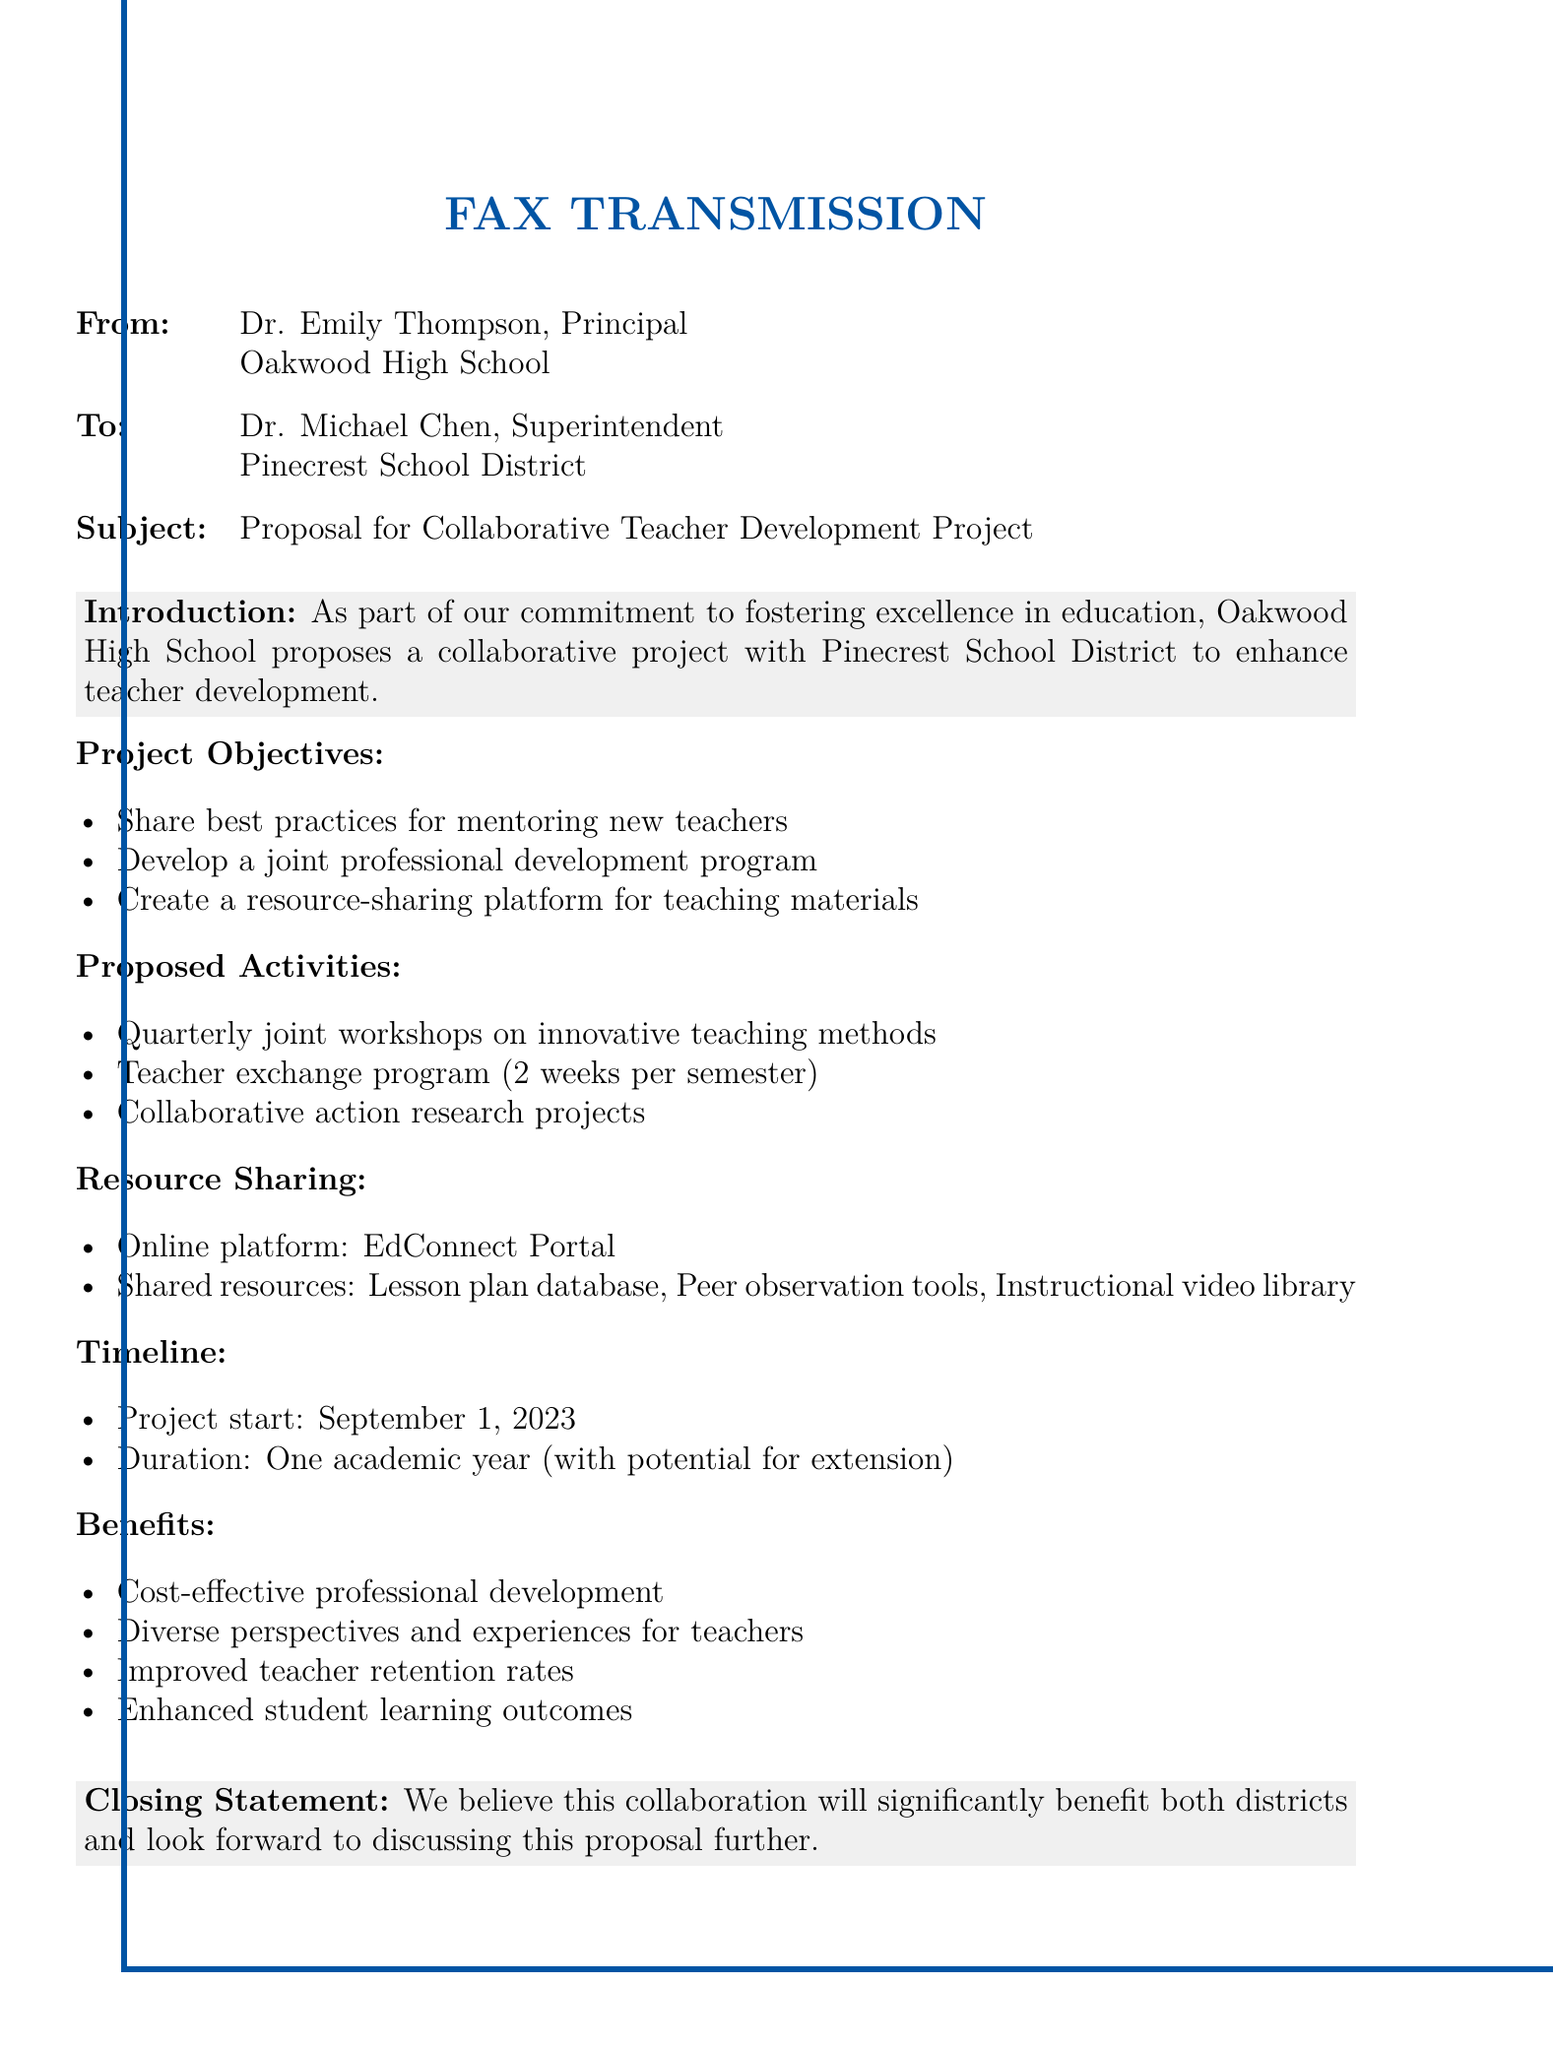What is the subject of the fax? The subject is clearly stated in the document as the proposal for a collaborative teacher development project.
Answer: Proposal for Collaborative Teacher Development Project Who is the sender of the fax? The sender's information is located at the beginning, mentioning Dr. Emily Thompson as the Principal of Oakwood High School.
Answer: Dr. Emily Thompson When is the project scheduled to start? The timeline section of the document specifies a start date for the project.
Answer: September 1, 2023 How long is the duration of the project? The duration of the project is mentioned explicitly in the timeline section.
Answer: One academic year What is one proposed activity in the project? The section on proposed activities lists several initiatives, one of which is the teacher exchange program.
Answer: Teacher exchange program What online platform is mentioned for resource sharing? The resource sharing section highlights the name of the online platform to be used.
Answer: EdConnect Portal What benefit is expected from this collaboration? The benefits section includes multiple advantages, one of which is improved teacher retention rates.
Answer: Improved teacher retention rates What is the main goal of the proposed project? The introduction of the document outlines the main purpose of the collaborative project.
Answer: Enhance teacher development What type of document is this? The overall structure and format of the presentation suggest that this is a fax transmission.
Answer: Fax transmission 